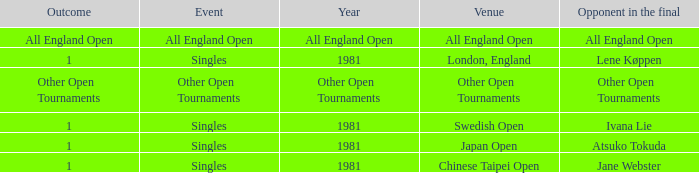What is the adversary in the finale with an all england open result? All England Open. I'm looking to parse the entire table for insights. Could you assist me with that? {'header': ['Outcome', 'Event', 'Year', 'Venue', 'Opponent in the final'], 'rows': [['All England Open', 'All England Open', 'All England Open', 'All England Open', 'All England Open'], ['1', 'Singles', '1981', 'London, England', 'Lene Køppen'], ['Other Open Tournaments', 'Other Open Tournaments', 'Other Open Tournaments', 'Other Open Tournaments', 'Other Open Tournaments'], ['1', 'Singles', '1981', 'Swedish Open', 'Ivana Lie'], ['1', 'Singles', '1981', 'Japan Open', 'Atsuko Tokuda'], ['1', 'Singles', '1981', 'Chinese Taipei Open', 'Jane Webster']]} 